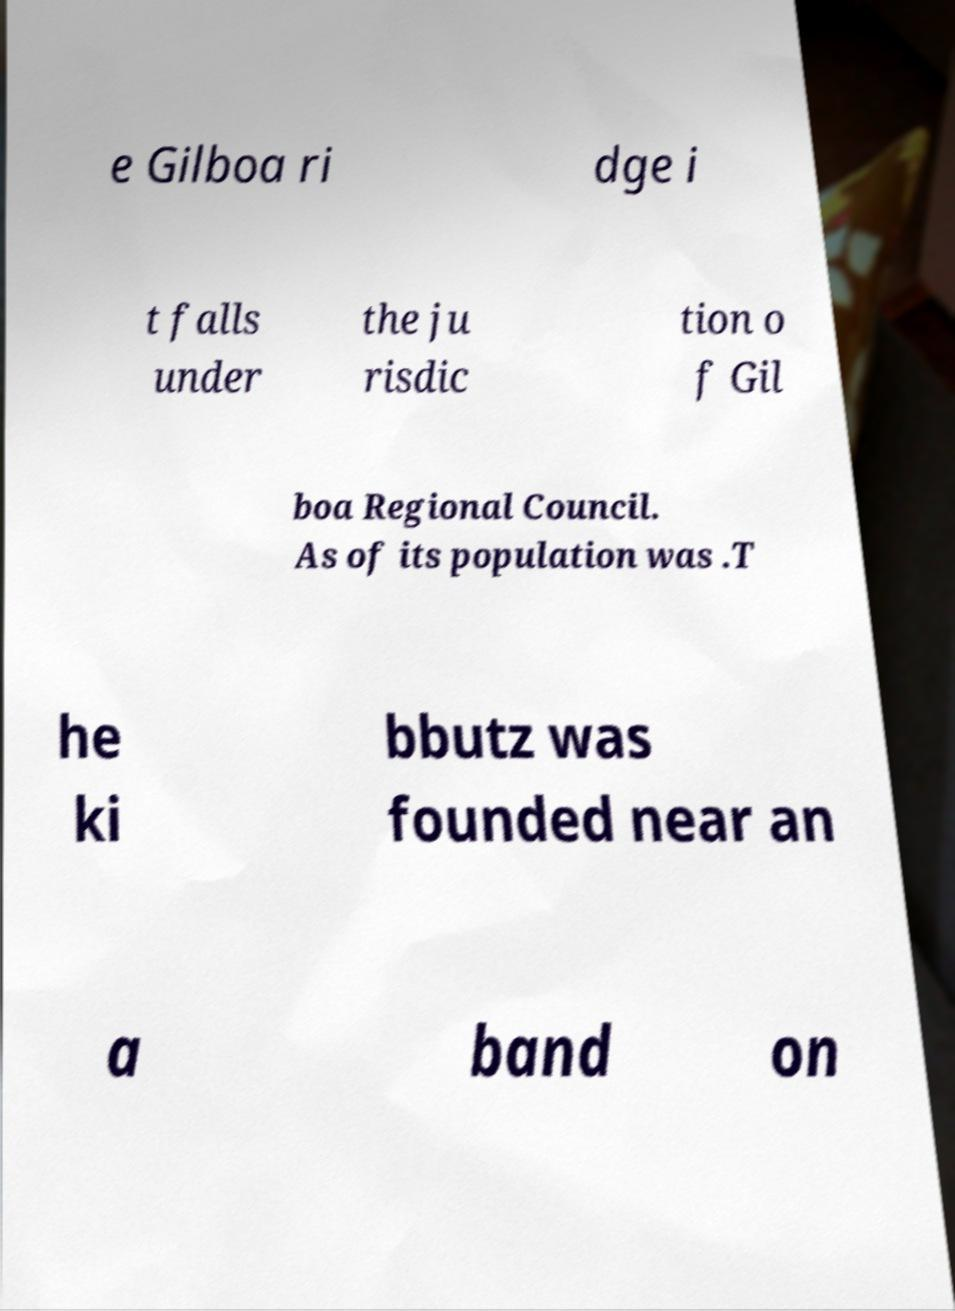Can you read and provide the text displayed in the image?This photo seems to have some interesting text. Can you extract and type it out for me? e Gilboa ri dge i t falls under the ju risdic tion o f Gil boa Regional Council. As of its population was .T he ki bbutz was founded near an a band on 